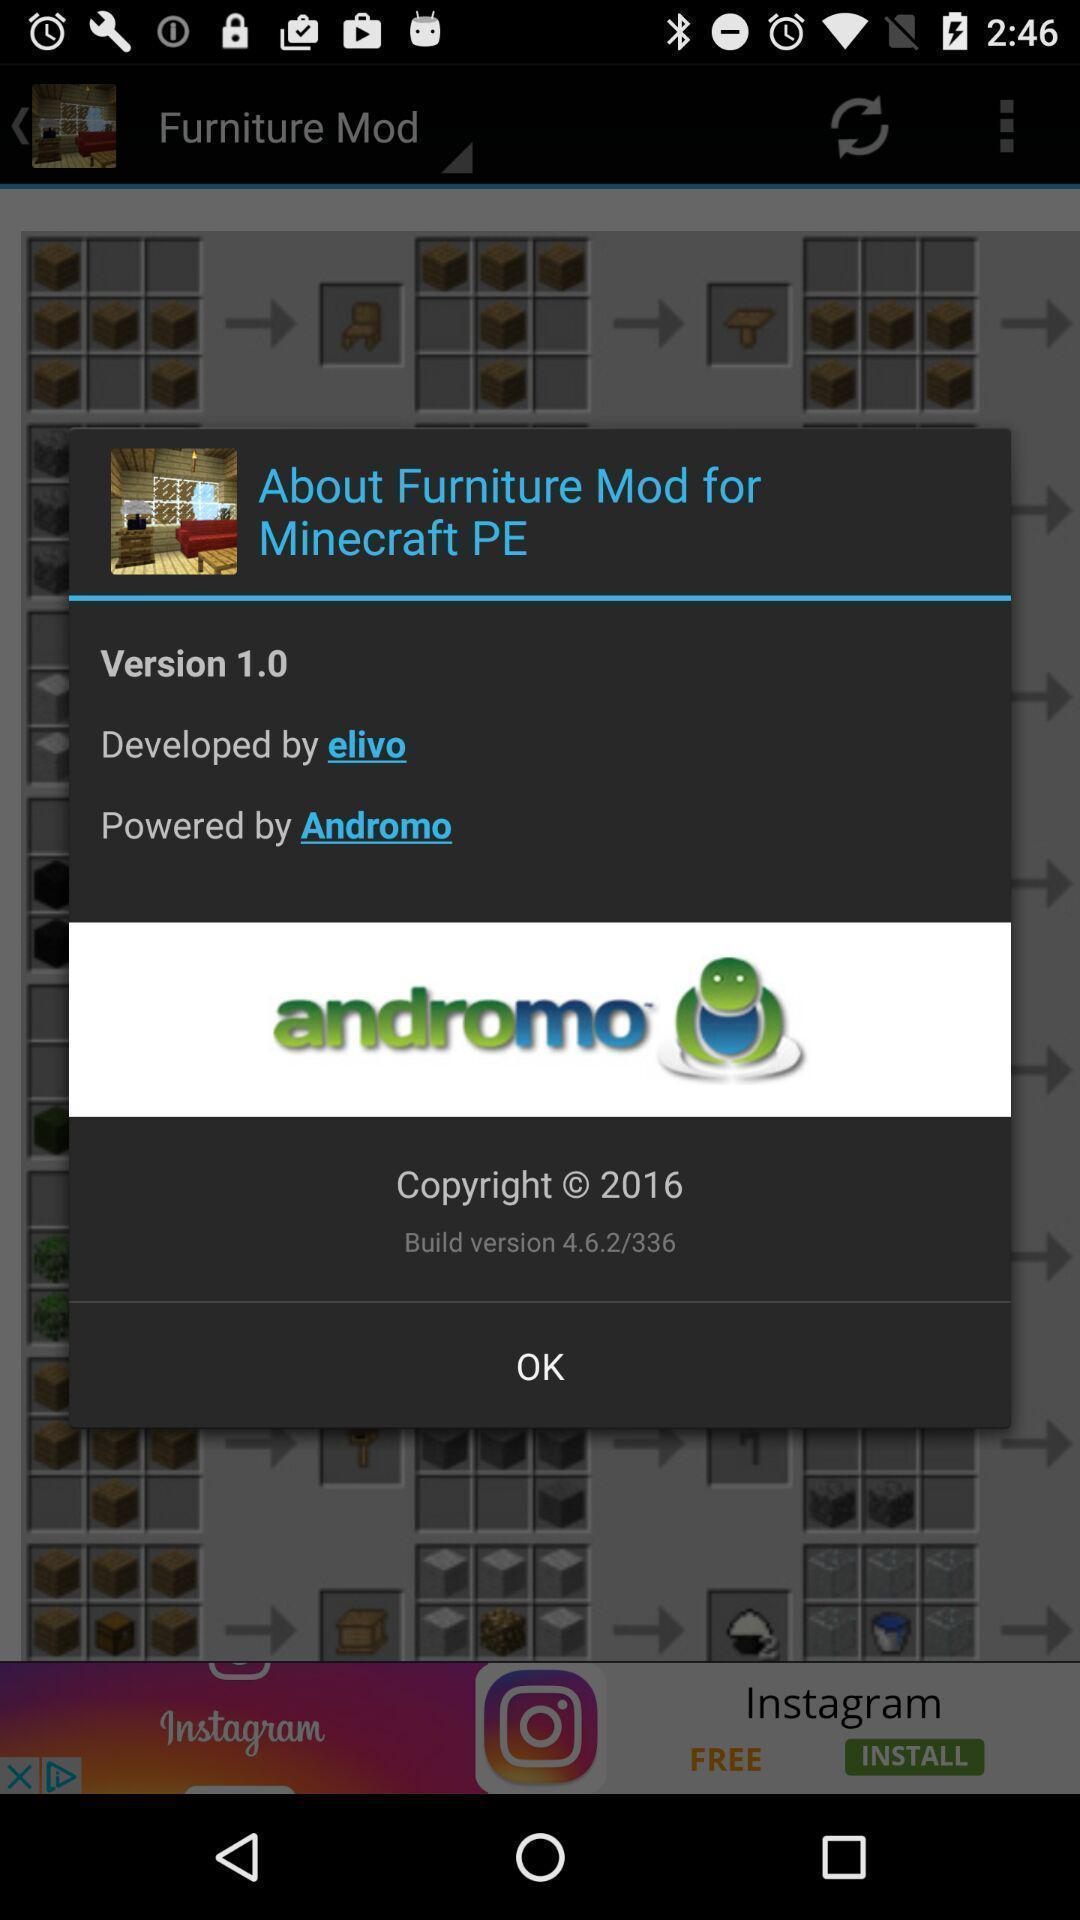Summarize the information in this screenshot. Popup showing some information with picture. 